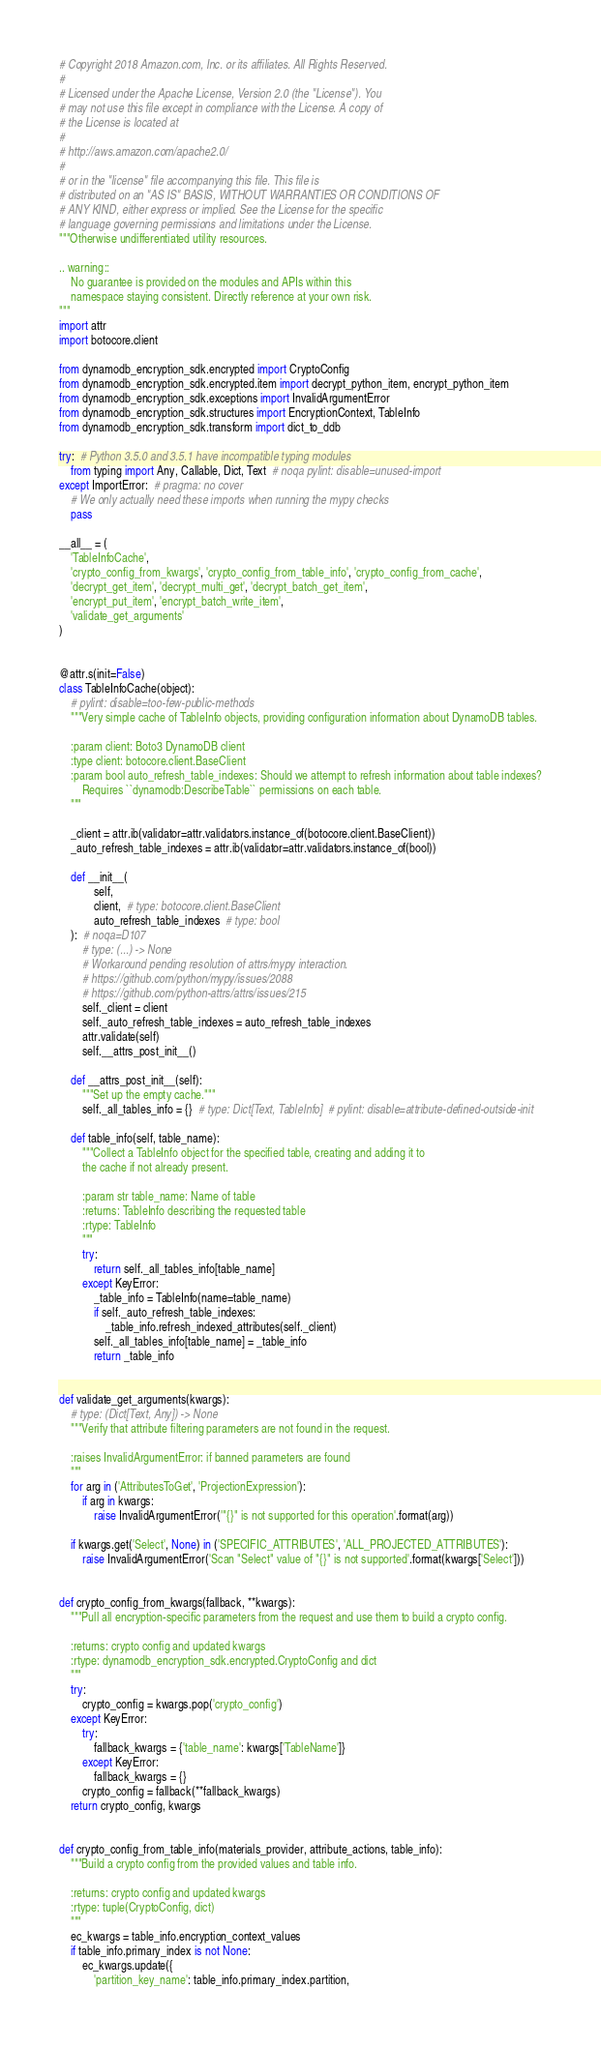Convert code to text. <code><loc_0><loc_0><loc_500><loc_500><_Python_># Copyright 2018 Amazon.com, Inc. or its affiliates. All Rights Reserved.
#
# Licensed under the Apache License, Version 2.0 (the "License"). You
# may not use this file except in compliance with the License. A copy of
# the License is located at
#
# http://aws.amazon.com/apache2.0/
#
# or in the "license" file accompanying this file. This file is
# distributed on an "AS IS" BASIS, WITHOUT WARRANTIES OR CONDITIONS OF
# ANY KIND, either express or implied. See the License for the specific
# language governing permissions and limitations under the License.
"""Otherwise undifferentiated utility resources.

.. warning::
    No guarantee is provided on the modules and APIs within this
    namespace staying consistent. Directly reference at your own risk.
"""
import attr
import botocore.client

from dynamodb_encryption_sdk.encrypted import CryptoConfig
from dynamodb_encryption_sdk.encrypted.item import decrypt_python_item, encrypt_python_item
from dynamodb_encryption_sdk.exceptions import InvalidArgumentError
from dynamodb_encryption_sdk.structures import EncryptionContext, TableInfo
from dynamodb_encryption_sdk.transform import dict_to_ddb

try:  # Python 3.5.0 and 3.5.1 have incompatible typing modules
    from typing import Any, Callable, Dict, Text  # noqa pylint: disable=unused-import
except ImportError:  # pragma: no cover
    # We only actually need these imports when running the mypy checks
    pass

__all__ = (
    'TableInfoCache',
    'crypto_config_from_kwargs', 'crypto_config_from_table_info', 'crypto_config_from_cache',
    'decrypt_get_item', 'decrypt_multi_get', 'decrypt_batch_get_item',
    'encrypt_put_item', 'encrypt_batch_write_item',
    'validate_get_arguments'
)


@attr.s(init=False)
class TableInfoCache(object):
    # pylint: disable=too-few-public-methods
    """Very simple cache of TableInfo objects, providing configuration information about DynamoDB tables.

    :param client: Boto3 DynamoDB client
    :type client: botocore.client.BaseClient
    :param bool auto_refresh_table_indexes: Should we attempt to refresh information about table indexes?
        Requires ``dynamodb:DescribeTable`` permissions on each table.
    """

    _client = attr.ib(validator=attr.validators.instance_of(botocore.client.BaseClient))
    _auto_refresh_table_indexes = attr.ib(validator=attr.validators.instance_of(bool))

    def __init__(
            self,
            client,  # type: botocore.client.BaseClient
            auto_refresh_table_indexes  # type: bool
    ):  # noqa=D107
        # type: (...) -> None
        # Workaround pending resolution of attrs/mypy interaction.
        # https://github.com/python/mypy/issues/2088
        # https://github.com/python-attrs/attrs/issues/215
        self._client = client
        self._auto_refresh_table_indexes = auto_refresh_table_indexes
        attr.validate(self)
        self.__attrs_post_init__()

    def __attrs_post_init__(self):
        """Set up the empty cache."""
        self._all_tables_info = {}  # type: Dict[Text, TableInfo]  # pylint: disable=attribute-defined-outside-init

    def table_info(self, table_name):
        """Collect a TableInfo object for the specified table, creating and adding it to
        the cache if not already present.

        :param str table_name: Name of table
        :returns: TableInfo describing the requested table
        :rtype: TableInfo
        """
        try:
            return self._all_tables_info[table_name]
        except KeyError:
            _table_info = TableInfo(name=table_name)
            if self._auto_refresh_table_indexes:
                _table_info.refresh_indexed_attributes(self._client)
            self._all_tables_info[table_name] = _table_info
            return _table_info


def validate_get_arguments(kwargs):
    # type: (Dict[Text, Any]) -> None
    """Verify that attribute filtering parameters are not found in the request.

    :raises InvalidArgumentError: if banned parameters are found
    """
    for arg in ('AttributesToGet', 'ProjectionExpression'):
        if arg in kwargs:
            raise InvalidArgumentError('"{}" is not supported for this operation'.format(arg))

    if kwargs.get('Select', None) in ('SPECIFIC_ATTRIBUTES', 'ALL_PROJECTED_ATTRIBUTES'):
        raise InvalidArgumentError('Scan "Select" value of "{}" is not supported'.format(kwargs['Select']))


def crypto_config_from_kwargs(fallback, **kwargs):
    """Pull all encryption-specific parameters from the request and use them to build a crypto config.

    :returns: crypto config and updated kwargs
    :rtype: dynamodb_encryption_sdk.encrypted.CryptoConfig and dict
    """
    try:
        crypto_config = kwargs.pop('crypto_config')
    except KeyError:
        try:
            fallback_kwargs = {'table_name': kwargs['TableName']}
        except KeyError:
            fallback_kwargs = {}
        crypto_config = fallback(**fallback_kwargs)
    return crypto_config, kwargs


def crypto_config_from_table_info(materials_provider, attribute_actions, table_info):
    """Build a crypto config from the provided values and table info.

    :returns: crypto config and updated kwargs
    :rtype: tuple(CryptoConfig, dict)
    """
    ec_kwargs = table_info.encryption_context_values
    if table_info.primary_index is not None:
        ec_kwargs.update({
            'partition_key_name': table_info.primary_index.partition,</code> 